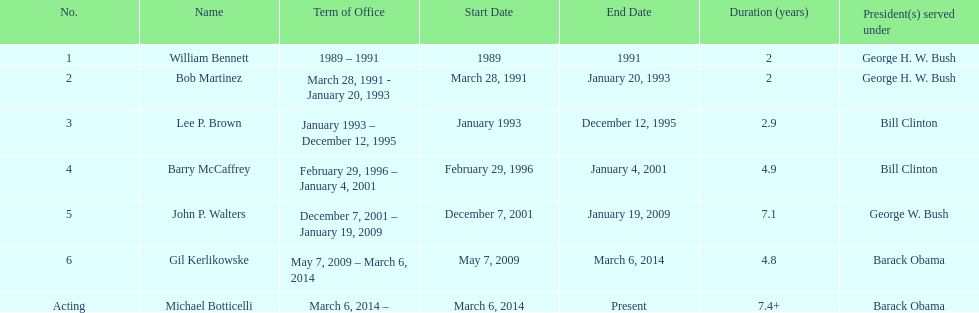When did john p. walters conclude his term? January 19, 2009. 